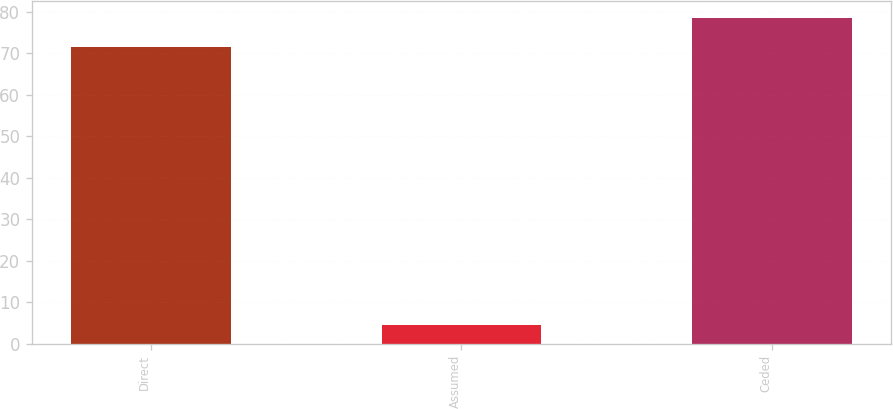<chart> <loc_0><loc_0><loc_500><loc_500><bar_chart><fcel>Direct<fcel>Assumed<fcel>Ceded<nl><fcel>71.5<fcel>4.4<fcel>78.65<nl></chart> 